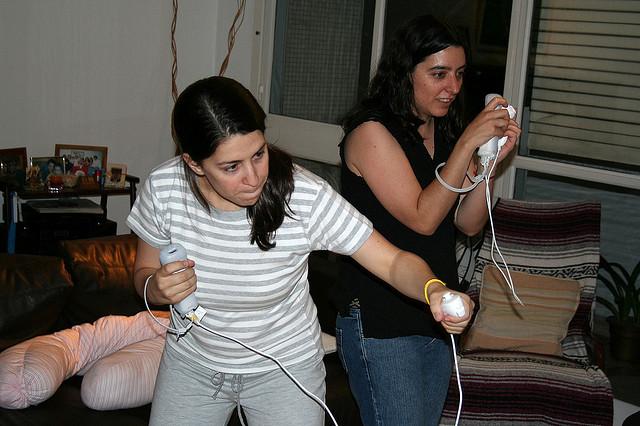What type of game machines are in the background?
Give a very brief answer. Wii. What are the women doing?
Concise answer only. Playing. What color nail does this woman have?
Quick response, please. Natural. Is there a white snake in the background?
Write a very short answer. No. Are these children brushing their teeth?
Write a very short answer. No. What is the color of the women's hair?
Quick response, please. Black. 